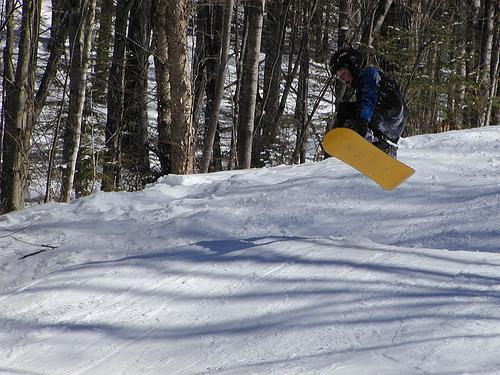How does the snow appear on the ground between the trees? The snow on the ground between the trees appears clumpy and white. What kind of trees can be seen behind the kid, and where are they placed in the image? Green pine trees are behind the kid, located towards the right side of the image. Mention the object in the air and its color. There's a snowboarder in the air with a yellow snowboard. What is the main protective gear being worn by the rider, and what color is it? The rider is wearing a black helmet for safety. List any other items found on the snowy ground. There are sticks laying on the snow and clumpy, white snow on the ground. What is the color of the rider's coat sleeves and what could be seen on the snowy slope? The rider has blue coat sleeves, and there's a shadow of trees on the snowy slope. Count the number of trees without leaves in the image. There are brown bare winter trees in the background. Describe the environment where the snowboarder is performing his tricks. The snowboarder is on a snowy slope for riding, with tree shadows on the snow and bare winter trees in the background. Briefly describe the snowboarder's position and what he is doing. The snowboarder is in midair, jumping with his yellow snowboard. What type of snow hill best describes the location of the snowboarder's jump? The snowboarder is on a snow hill designed for jumping, surrounded by trees and shadows on the slope. Can you locate the red sled in the image? Make sure to adjust its color contrast. No, it's not mentioned in the image. Please look for the snowman near the bottom-right corner of the image and describe its facial features. There is no mention of a snowman in any of the given information about objects in the image. The instruction is misleading as it asks the viewer to look for a non-existent snowman and describe its facial features, which are not present in the image. Would you mind noting the beautiful birds perched on the tree branches? You can also enhance their visibility using filters. There are no birds mentioned in any of the given information about objects in the image. This instruction is misleading as it directs the viewer to look for non-existent birds and gives suggestions on enhancing their visibility, which is irrelevant. Kindly focus on the little dog wearing a snowsuit to the right of the snowboarder. Observe how it is enjoying the winter season. There is no mention of a dog in any of the given information about objects in the image. The misleading instruction asks the viewer to focus on a non-existent dog wearing a snowsuit, and even provides an emotional context (enjoying the winter season) that is not applicable. Concentrate on the ski lift on the left side of the image and describe its structure and color. There is no ski lift mentioned in any of the given information about objects in the image. The instruction is misleading as it directs the viewer to look for a non-existent ski lift and describe its structure and color, which are not present in the image. 